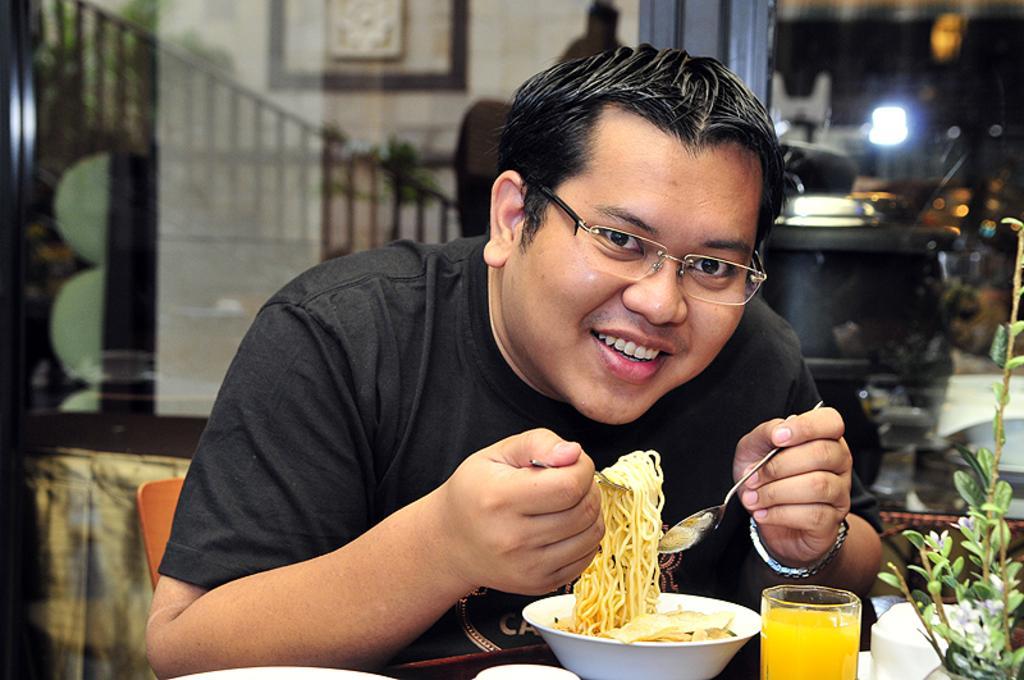Can you describe this image briefly? This image is taken indoors. In the background there is a wall with a picture frame and there is a railing. On the right side of the image there are a few things and there are a few lights. There is a plant. At the bottom of the image there is a table with a glass of juice, a cup, a plate, a plant and a bowl with noodles on it. In the middle of the image a man is sitting on the chair and he is holding a spoon and a fork with noodles in his hands. 